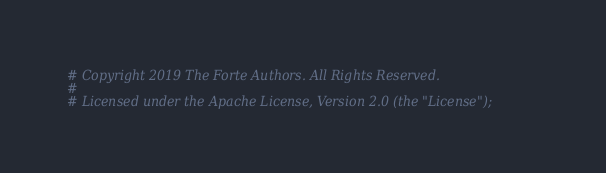<code> <loc_0><loc_0><loc_500><loc_500><_Python_># Copyright 2019 The Forte Authors. All Rights Reserved.
#
# Licensed under the Apache License, Version 2.0 (the "License");</code> 